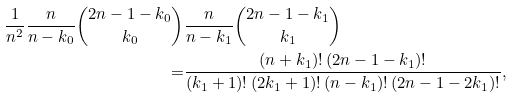Convert formula to latex. <formula><loc_0><loc_0><loc_500><loc_500>\frac { 1 } { n ^ { 2 } } \frac { n } { n - k _ { 0 } } \binom { 2 n - 1 - k _ { 0 } } { k _ { 0 } } & \frac { n } { n - k _ { 1 } } \binom { 2 n - 1 - k _ { 1 } } { k _ { 1 } } \\ = & \frac { ( n + k _ { 1 } ) ! \, ( 2 n - 1 - k _ { 1 } ) ! } { ( k _ { 1 } + 1 ) ! \, ( 2 k _ { 1 } + 1 ) ! \, ( n - k _ { 1 } ) ! \, ( 2 n - 1 - 2 k _ { 1 } ) ! } ,</formula> 